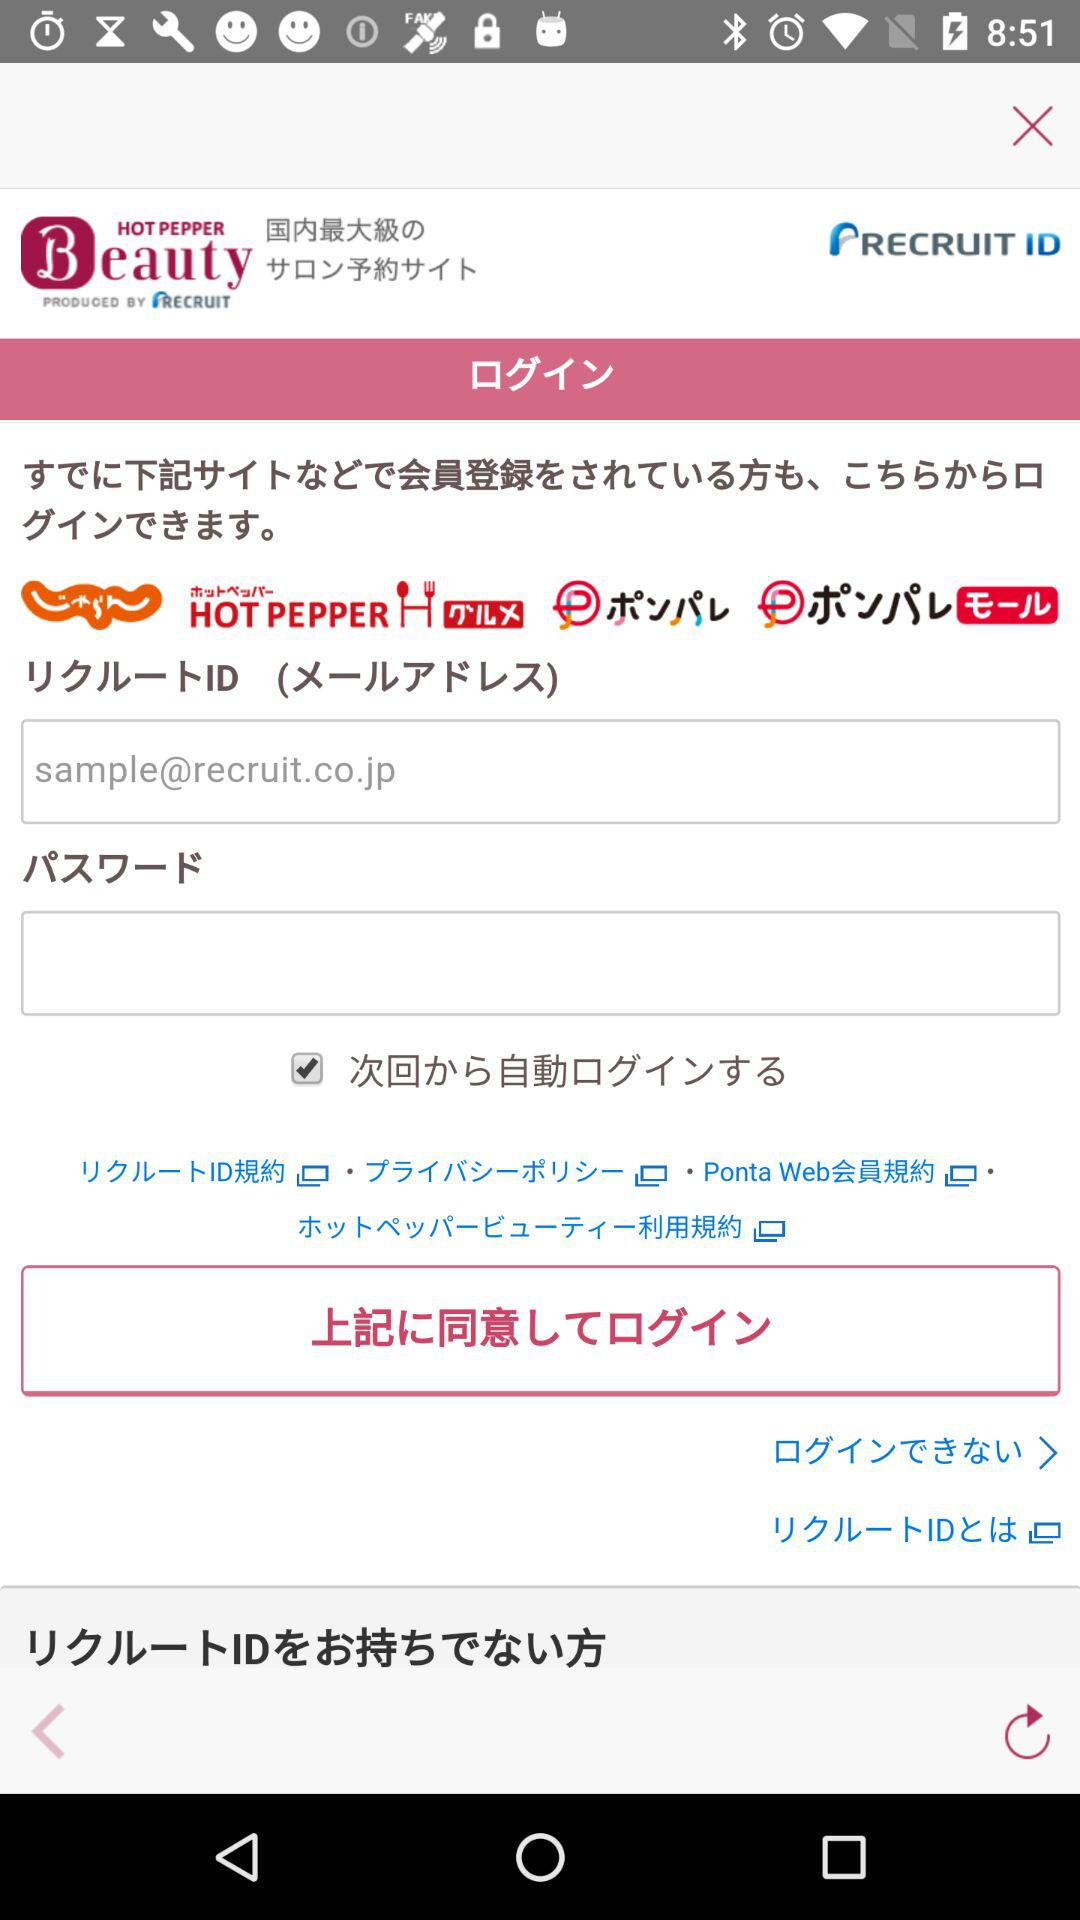How many text input fields are there in the login screen?
Answer the question using a single word or phrase. 2 